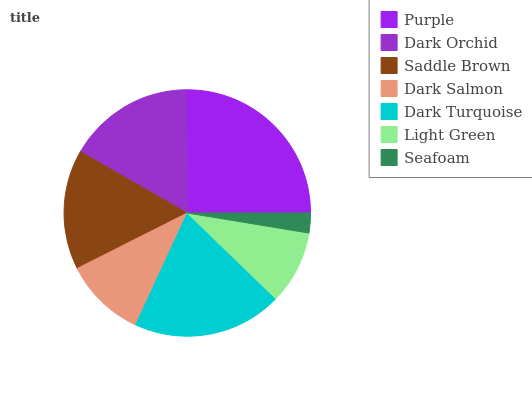Is Seafoam the minimum?
Answer yes or no. Yes. Is Purple the maximum?
Answer yes or no. Yes. Is Dark Orchid the minimum?
Answer yes or no. No. Is Dark Orchid the maximum?
Answer yes or no. No. Is Purple greater than Dark Orchid?
Answer yes or no. Yes. Is Dark Orchid less than Purple?
Answer yes or no. Yes. Is Dark Orchid greater than Purple?
Answer yes or no. No. Is Purple less than Dark Orchid?
Answer yes or no. No. Is Saddle Brown the high median?
Answer yes or no. Yes. Is Saddle Brown the low median?
Answer yes or no. Yes. Is Purple the high median?
Answer yes or no. No. Is Dark Orchid the low median?
Answer yes or no. No. 